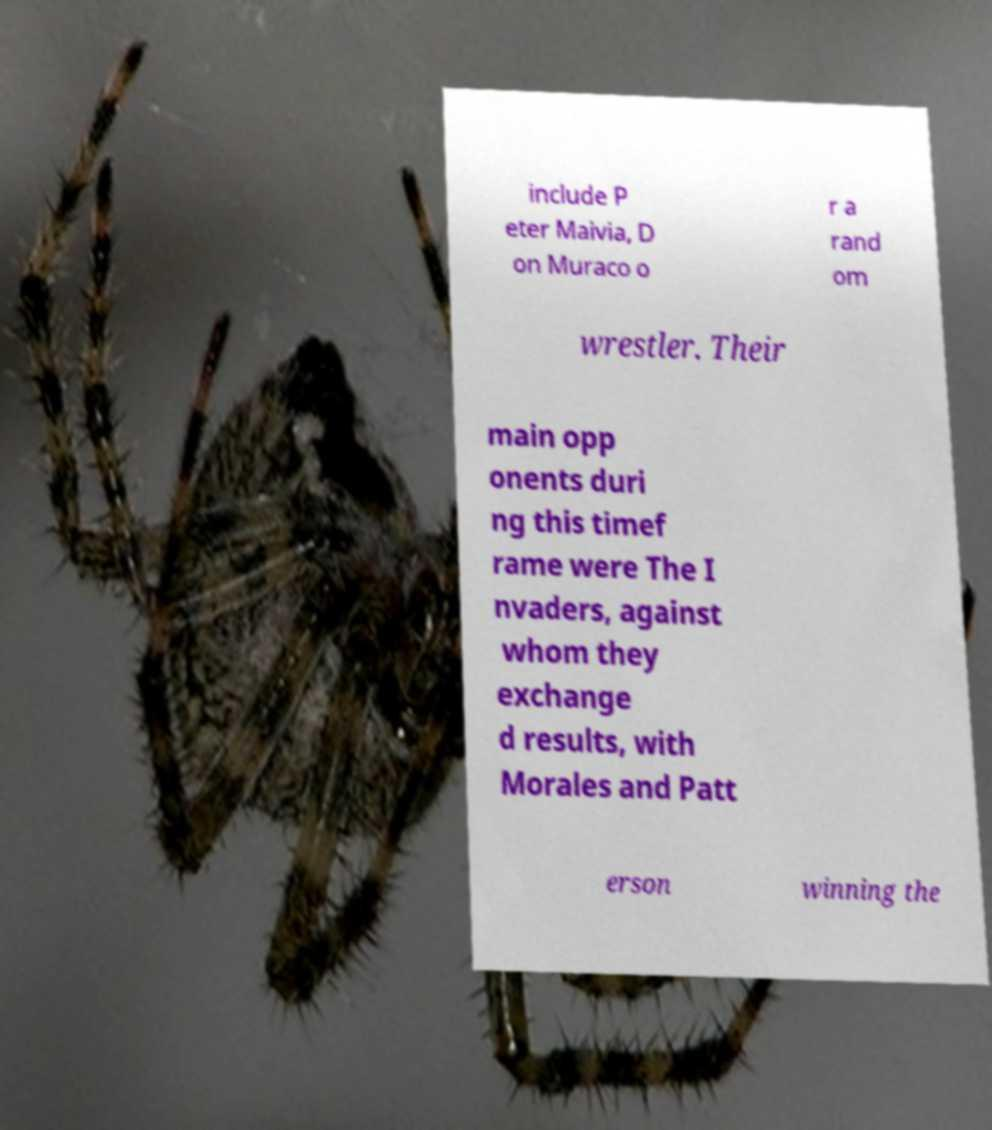Please identify and transcribe the text found in this image. include P eter Maivia, D on Muraco o r a rand om wrestler. Their main opp onents duri ng this timef rame were The I nvaders, against whom they exchange d results, with Morales and Patt erson winning the 